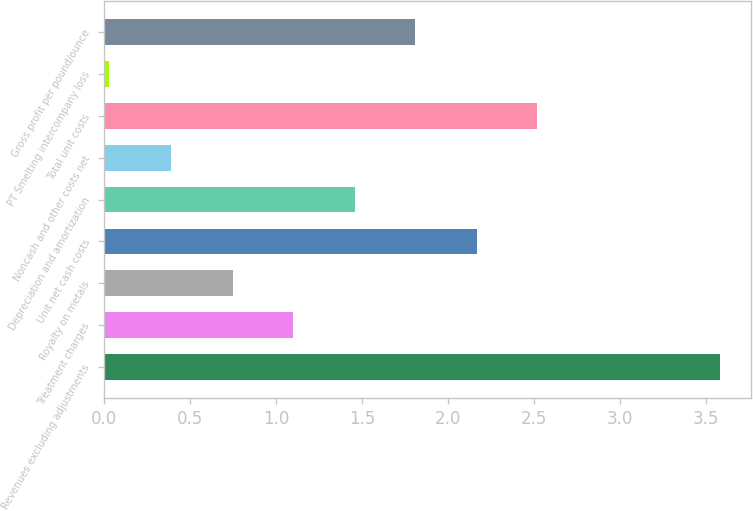Convert chart. <chart><loc_0><loc_0><loc_500><loc_500><bar_chart><fcel>Revenues excluding adjustments<fcel>Treatment charges<fcel>Royalty on metals<fcel>Unit net cash costs<fcel>Depreciation and amortization<fcel>Noncash and other costs net<fcel>Total unit costs<fcel>PT Smelting intercompany loss<fcel>Gross profit per pound/ounce<nl><fcel>3.58<fcel>1.1<fcel>0.75<fcel>2.17<fcel>1.46<fcel>0.39<fcel>2.52<fcel>0.03<fcel>1.81<nl></chart> 